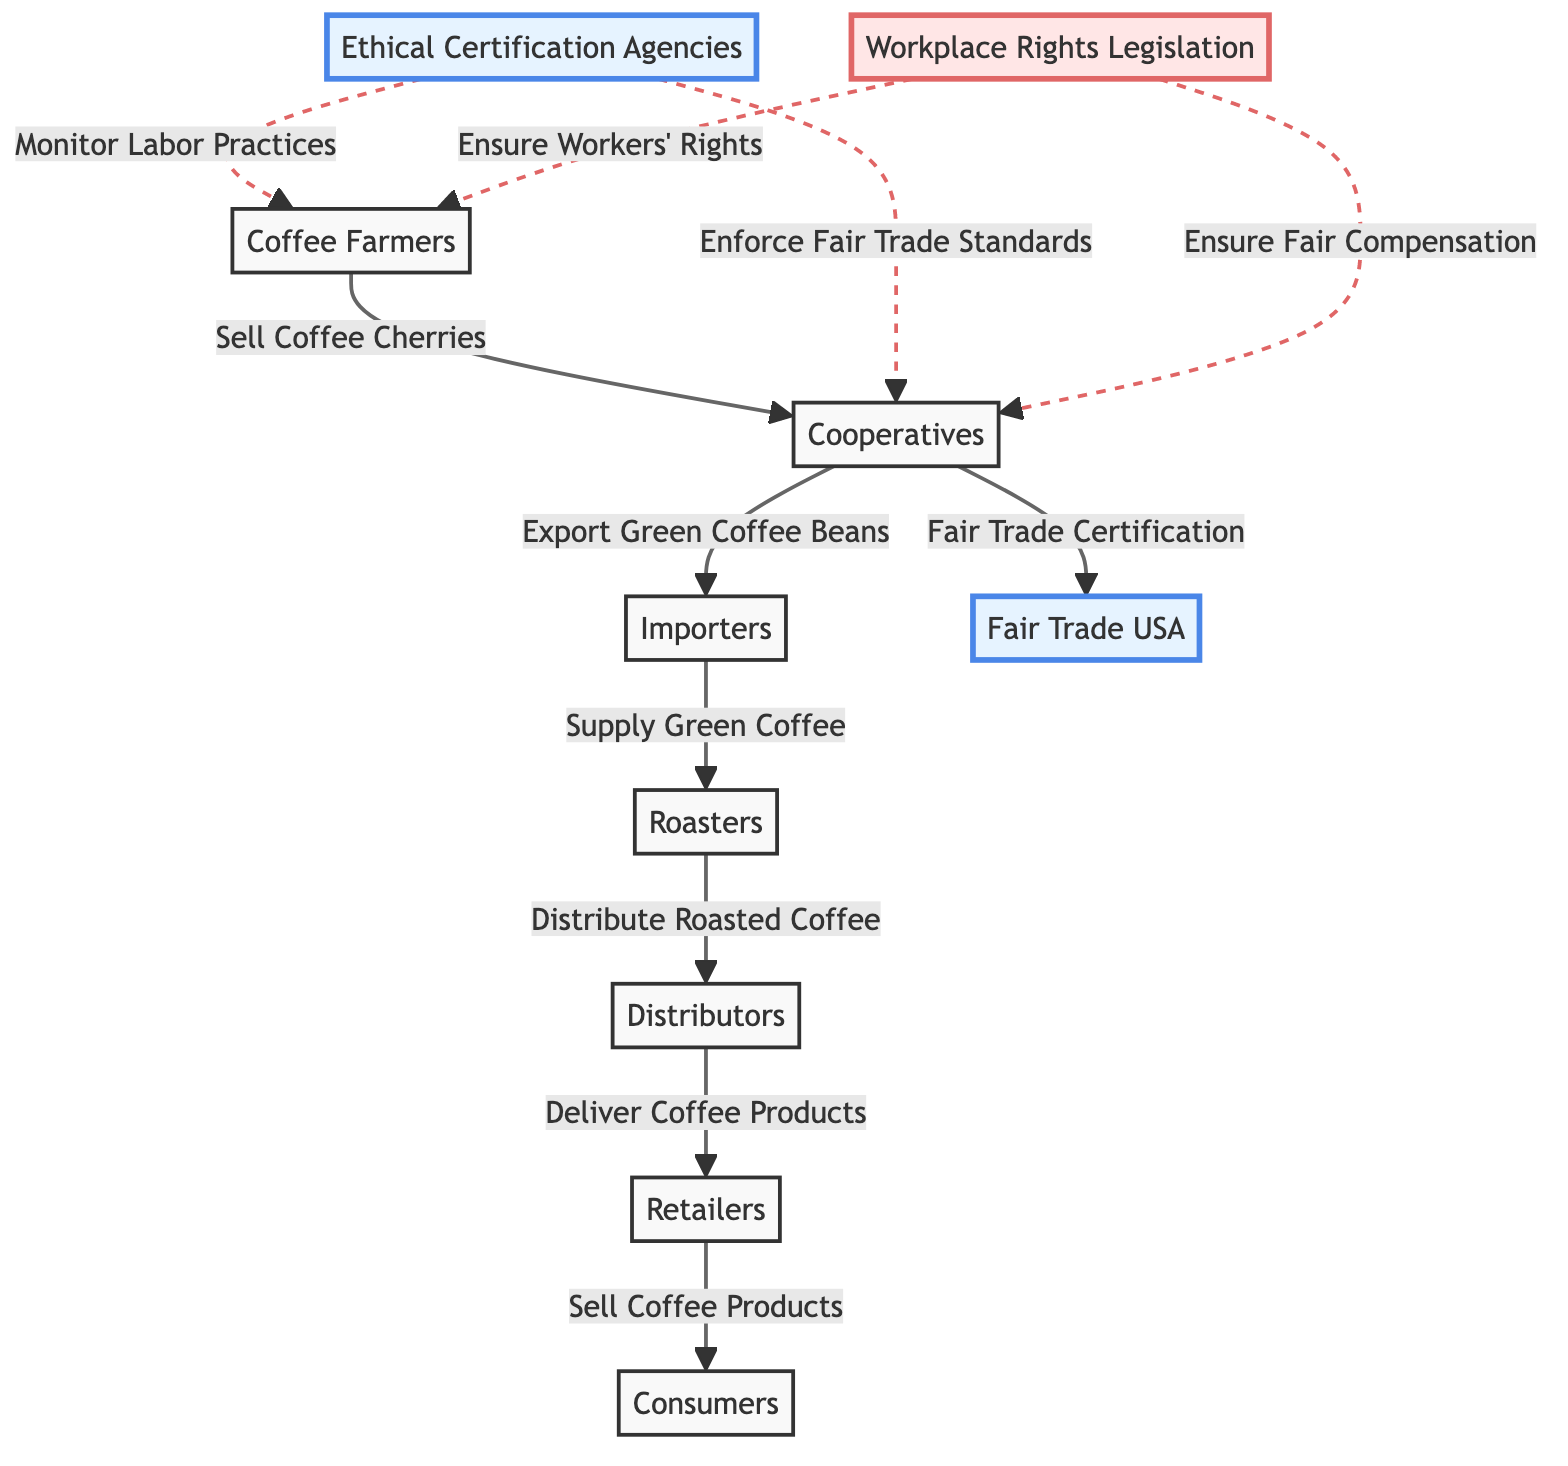What are the first entities in the supply chain? The diagram begins with "Coffee Farmers" and "Cooperatives" as the first entities in the supply chain. They are interconnected, with farmers selling coffee cherries to cooperatives.
Answer: Coffee Farmers, Cooperatives Who certifies the cooperatives for fair trade? "Fair Trade USA" is linked directly to "Cooperatives" as the certification authority for fair trade, indicating that they certify the cooperatives.
Answer: Fair Trade USA How many main entities are involved in the supply chain? There are seven main entities displayed in the supply chain: Coffee Farmers, Cooperatives, Importers, Roasters, Distributors, Retailers, and Consumers. By counting these nodes, we determine the total.
Answer: 7 What type of monitoring is conducted on farmers? "Ethical Certification Agencies" perform the monitoring of labor practices on the "Coffee Farmers," ensuring compliance with ethical standards.
Answer: Monitor Labor Practices Which node represents the endpoint in the supply chain? The last entity in the flow of the diagram, which represents the endpoint where the product reaches the consumer, is "Consumers."
Answer: Consumers What type of relationship exists between "Cooperatives" and "Green Coffee Beans"? The relationship is established through the action of "Export Green Coffee Beans," indicating that cooperatives export the beans to importers.
Answer: Export Green Coffee Beans How does workplace rights legislation affect farmers? "Workplace Rights Legislation" enforces rights on "Farmers," ensuring that their labor rights and fair compensation are upheld. This connection illustrates the legislation's impact on the workforce.
Answer: Ensure Workers' Rights What is one key responsibility of ethical certification agencies towards cooperatives? Ethical certification agencies are responsible for enforcing fair trade standards on cooperatives, making sure they adhere to established guidelines for ethical sourcing.
Answer: Enforce Fair Trade Standards What flows from "Roasters" to "Distributors"? "Roasters" distribute roasted coffee to "Distributors," indicating the movement of the product in the supply chain from one entity to another.
Answer: Distribute Roasted Coffee 